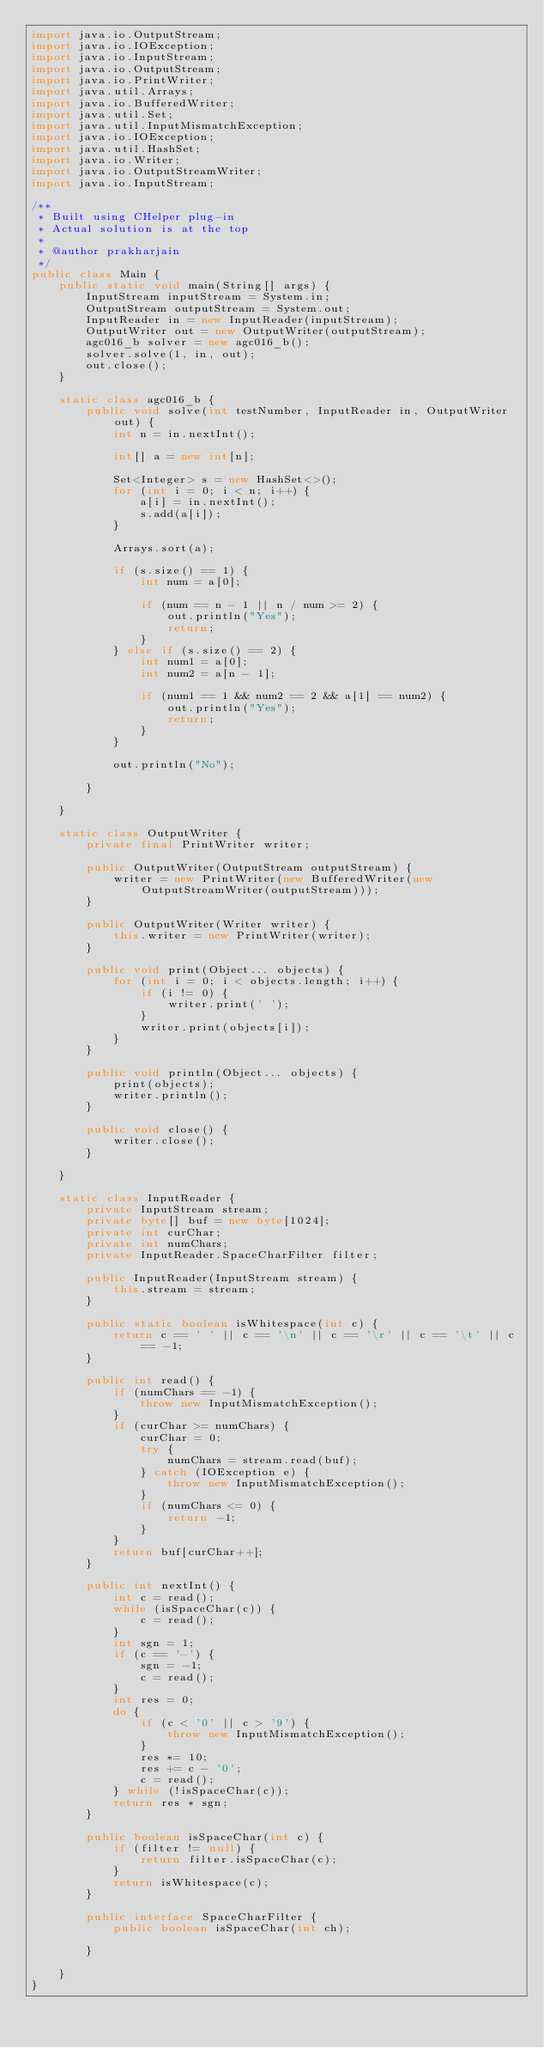<code> <loc_0><loc_0><loc_500><loc_500><_Java_>import java.io.OutputStream;
import java.io.IOException;
import java.io.InputStream;
import java.io.OutputStream;
import java.io.PrintWriter;
import java.util.Arrays;
import java.io.BufferedWriter;
import java.util.Set;
import java.util.InputMismatchException;
import java.io.IOException;
import java.util.HashSet;
import java.io.Writer;
import java.io.OutputStreamWriter;
import java.io.InputStream;

/**
 * Built using CHelper plug-in
 * Actual solution is at the top
 *
 * @author prakharjain
 */
public class Main {
    public static void main(String[] args) {
        InputStream inputStream = System.in;
        OutputStream outputStream = System.out;
        InputReader in = new InputReader(inputStream);
        OutputWriter out = new OutputWriter(outputStream);
        agc016_b solver = new agc016_b();
        solver.solve(1, in, out);
        out.close();
    }

    static class agc016_b {
        public void solve(int testNumber, InputReader in, OutputWriter out) {
            int n = in.nextInt();

            int[] a = new int[n];

            Set<Integer> s = new HashSet<>();
            for (int i = 0; i < n; i++) {
                a[i] = in.nextInt();
                s.add(a[i]);
            }

            Arrays.sort(a);

            if (s.size() == 1) {
                int num = a[0];

                if (num == n - 1 || n / num >= 2) {
                    out.println("Yes");
                    return;
                }
            } else if (s.size() == 2) {
                int num1 = a[0];
                int num2 = a[n - 1];

                if (num1 == 1 && num2 == 2 && a[1] == num2) {
                    out.println("Yes");
                    return;
                }
            }

            out.println("No");

        }

    }

    static class OutputWriter {
        private final PrintWriter writer;

        public OutputWriter(OutputStream outputStream) {
            writer = new PrintWriter(new BufferedWriter(new OutputStreamWriter(outputStream)));
        }

        public OutputWriter(Writer writer) {
            this.writer = new PrintWriter(writer);
        }

        public void print(Object... objects) {
            for (int i = 0; i < objects.length; i++) {
                if (i != 0) {
                    writer.print(' ');
                }
                writer.print(objects[i]);
            }
        }

        public void println(Object... objects) {
            print(objects);
            writer.println();
        }

        public void close() {
            writer.close();
        }

    }

    static class InputReader {
        private InputStream stream;
        private byte[] buf = new byte[1024];
        private int curChar;
        private int numChars;
        private InputReader.SpaceCharFilter filter;

        public InputReader(InputStream stream) {
            this.stream = stream;
        }

        public static boolean isWhitespace(int c) {
            return c == ' ' || c == '\n' || c == '\r' || c == '\t' || c == -1;
        }

        public int read() {
            if (numChars == -1) {
                throw new InputMismatchException();
            }
            if (curChar >= numChars) {
                curChar = 0;
                try {
                    numChars = stream.read(buf);
                } catch (IOException e) {
                    throw new InputMismatchException();
                }
                if (numChars <= 0) {
                    return -1;
                }
            }
            return buf[curChar++];
        }

        public int nextInt() {
            int c = read();
            while (isSpaceChar(c)) {
                c = read();
            }
            int sgn = 1;
            if (c == '-') {
                sgn = -1;
                c = read();
            }
            int res = 0;
            do {
                if (c < '0' || c > '9') {
                    throw new InputMismatchException();
                }
                res *= 10;
                res += c - '0';
                c = read();
            } while (!isSpaceChar(c));
            return res * sgn;
        }

        public boolean isSpaceChar(int c) {
            if (filter != null) {
                return filter.isSpaceChar(c);
            }
            return isWhitespace(c);
        }

        public interface SpaceCharFilter {
            public boolean isSpaceChar(int ch);

        }

    }
}

</code> 